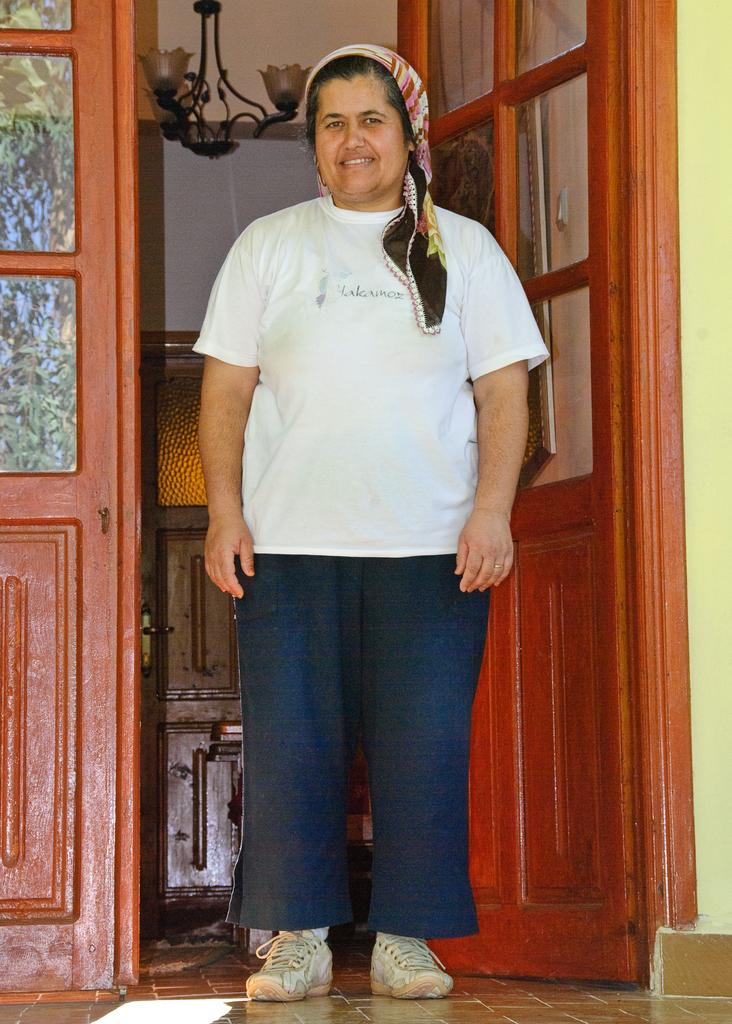Who or what is present in the image? There is a person in the image. What can be seen in the background of the image? There is a door in the image. What detail can be observed on the person's glasses? There are reflections on the glasses at the left side of the image. What type of lighting is present in the image? There are lamps in the image. Where is the spy hiding in the image? There is no spy present in the image, so it is not possible to determine where they might be hiding. 